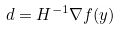Convert formula to latex. <formula><loc_0><loc_0><loc_500><loc_500>d = H ^ { - 1 } \nabla f ( y )</formula> 